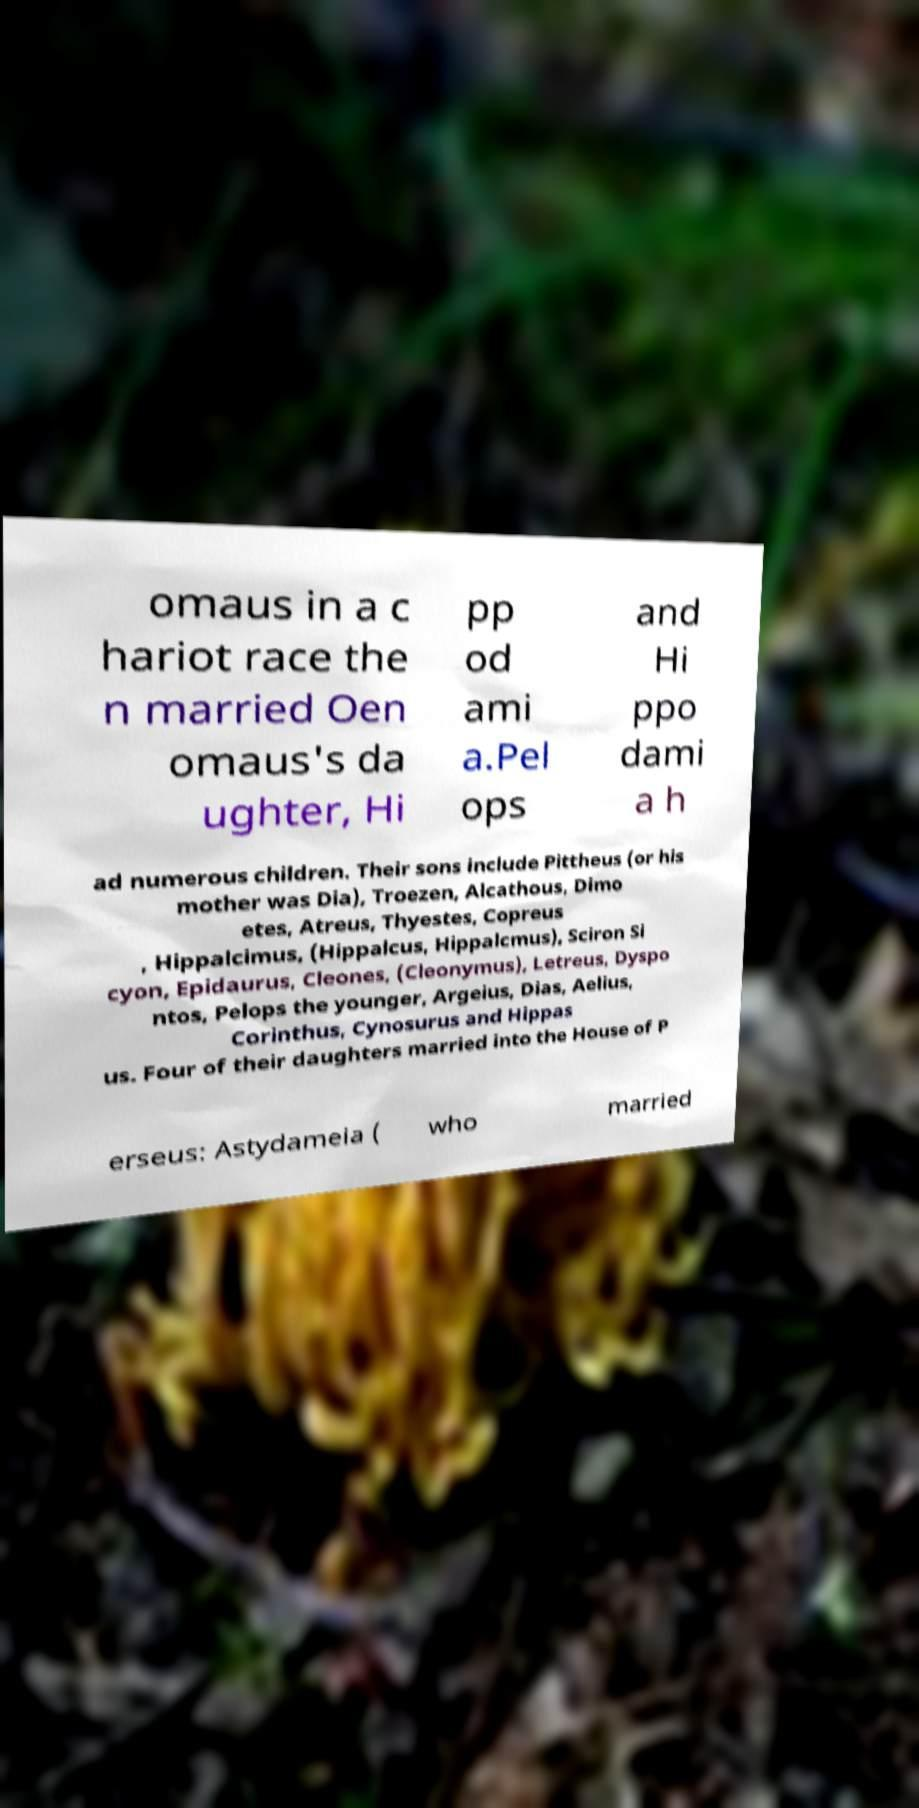Please read and relay the text visible in this image. What does it say? omaus in a c hariot race the n married Oen omaus's da ughter, Hi pp od ami a.Pel ops and Hi ppo dami a h ad numerous children. Their sons include Pittheus (or his mother was Dia), Troezen, Alcathous, Dimo etes, Atreus, Thyestes, Copreus , Hippalcimus, (Hippalcus, Hippalcmus), Sciron Si cyon, Epidaurus, Cleones, (Cleonymus), Letreus, Dyspo ntos, Pelops the younger, Argeius, Dias, Aelius, Corinthus, Cynosurus and Hippas us. Four of their daughters married into the House of P erseus: Astydameia ( who married 